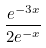Convert formula to latex. <formula><loc_0><loc_0><loc_500><loc_500>\frac { e ^ { - 3 x } } { 2 e ^ { - x } }</formula> 